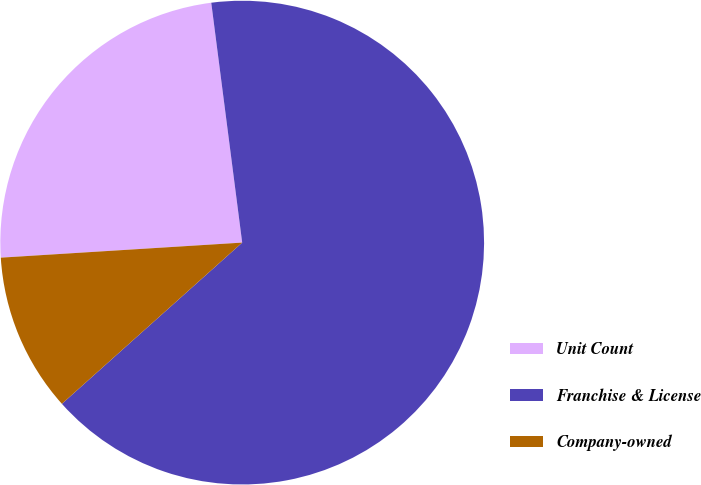Convert chart to OTSL. <chart><loc_0><loc_0><loc_500><loc_500><pie_chart><fcel>Unit Count<fcel>Franchise & License<fcel>Company-owned<nl><fcel>23.95%<fcel>65.43%<fcel>10.62%<nl></chart> 